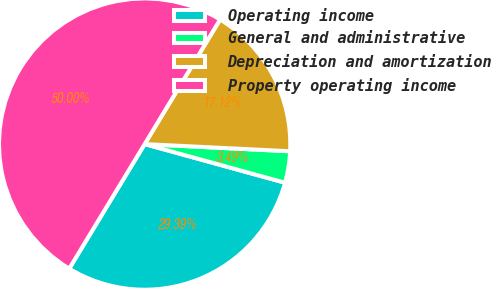Convert chart. <chart><loc_0><loc_0><loc_500><loc_500><pie_chart><fcel>Operating income<fcel>General and administrative<fcel>Depreciation and amortization<fcel>Property operating income<nl><fcel>29.39%<fcel>3.49%<fcel>17.12%<fcel>50.0%<nl></chart> 